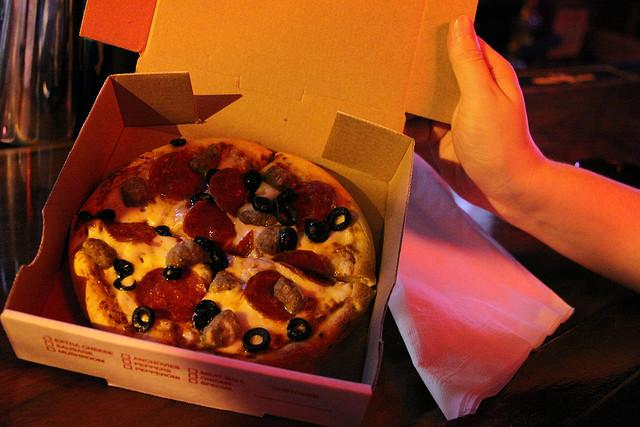What type person would enjoy this pizza?

Choices:
A) no one
B) vegan
C) omnivore
D) vegetarian omnivore 